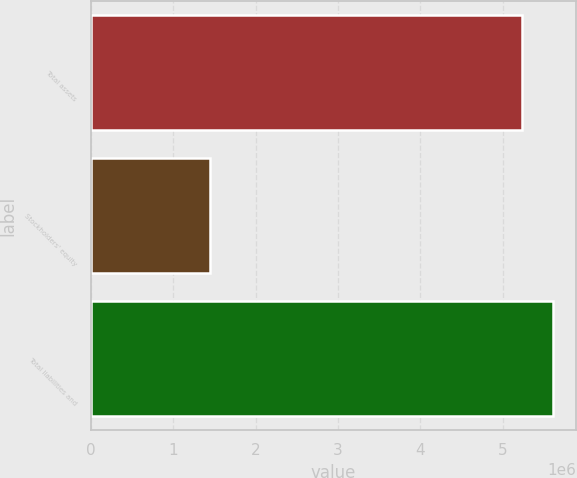Convert chart to OTSL. <chart><loc_0><loc_0><loc_500><loc_500><bar_chart><fcel>Total assets<fcel>Stockholders' equity<fcel>Total liabilities and<nl><fcel>5.23432e+06<fcel>1.44063e+06<fcel>5.61369e+06<nl></chart> 